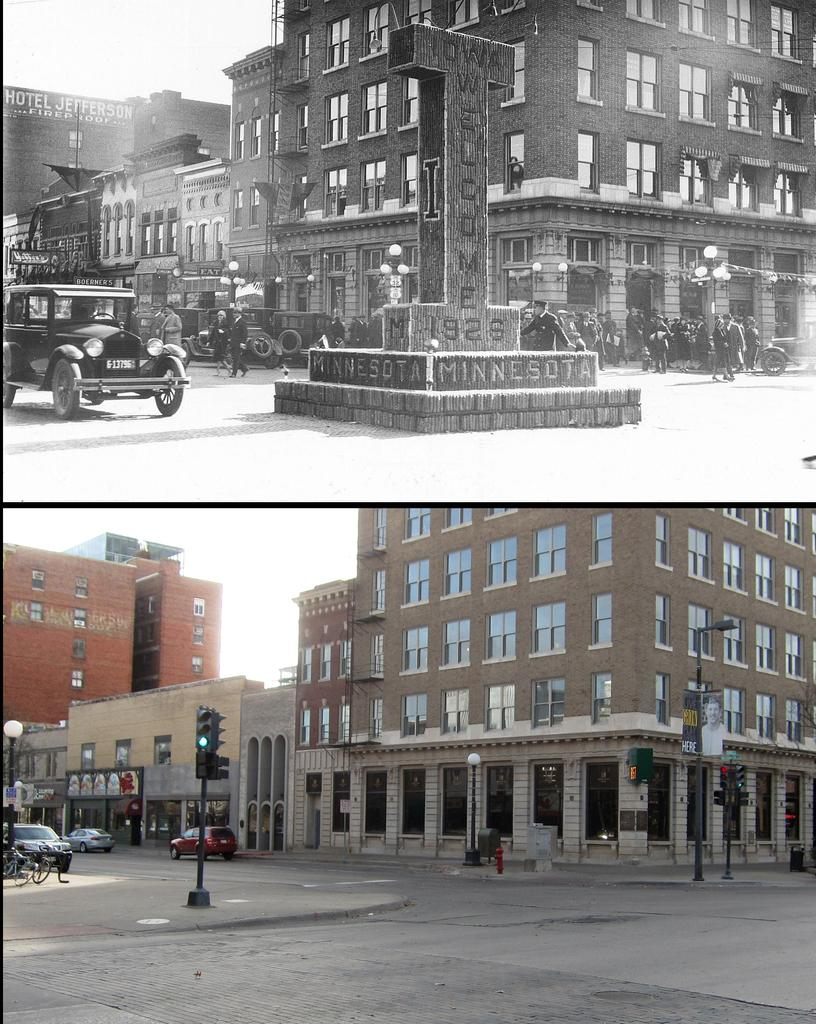What type of artwork is depicted in the image? The image is a collage. Can you describe the color scheme of the collage? The collage contains both black and white and color images. What type of whip is featured in the collage? There is no whip present in the collage; it contains a variety of images, but none of them feature a whip. How does the chin of the person in the collage look? There is no person with a chin present in the collage; it is a collection of images, not a single portrait or photograph. 